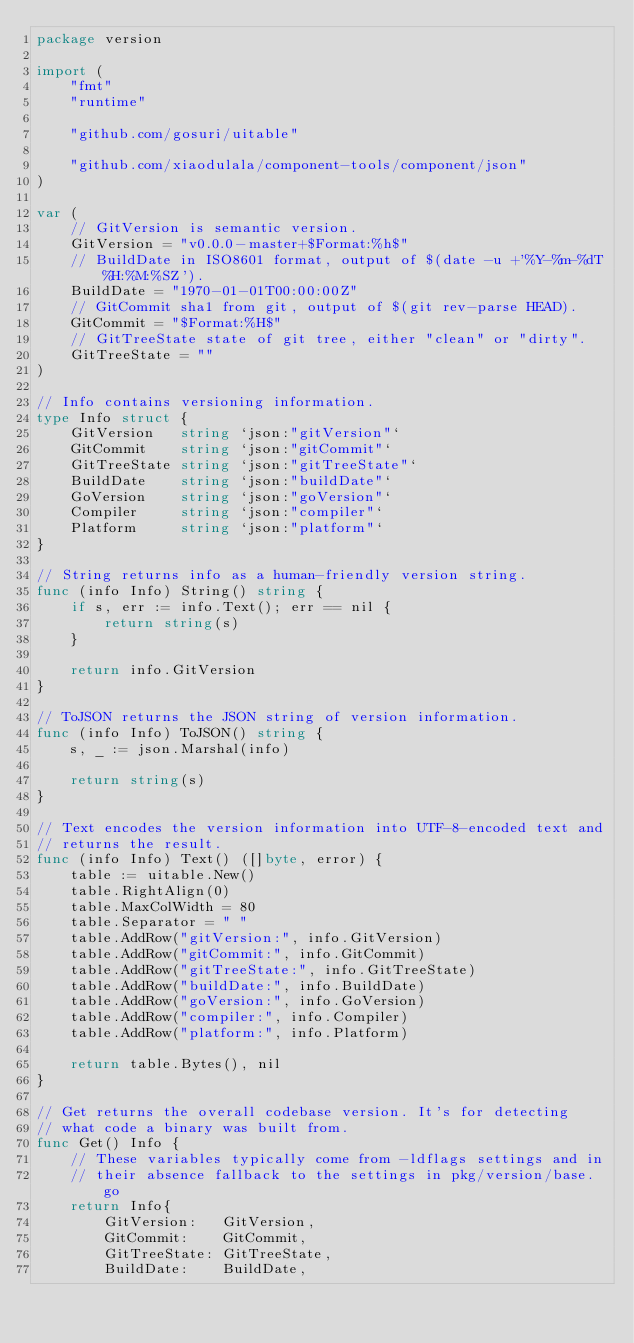<code> <loc_0><loc_0><loc_500><loc_500><_Go_>package version

import (
	"fmt"
	"runtime"

	"github.com/gosuri/uitable"

	"github.com/xiaodulala/component-tools/component/json"
)

var (
	// GitVersion is semantic version.
	GitVersion = "v0.0.0-master+$Format:%h$"
	// BuildDate in ISO8601 format, output of $(date -u +'%Y-%m-%dT%H:%M:%SZ').
	BuildDate = "1970-01-01T00:00:00Z"
	// GitCommit sha1 from git, output of $(git rev-parse HEAD).
	GitCommit = "$Format:%H$"
	// GitTreeState state of git tree, either "clean" or "dirty".
	GitTreeState = ""
)

// Info contains versioning information.
type Info struct {
	GitVersion   string `json:"gitVersion"`
	GitCommit    string `json:"gitCommit"`
	GitTreeState string `json:"gitTreeState"`
	BuildDate    string `json:"buildDate"`
	GoVersion    string `json:"goVersion"`
	Compiler     string `json:"compiler"`
	Platform     string `json:"platform"`
}

// String returns info as a human-friendly version string.
func (info Info) String() string {
	if s, err := info.Text(); err == nil {
		return string(s)
	}

	return info.GitVersion
}

// ToJSON returns the JSON string of version information.
func (info Info) ToJSON() string {
	s, _ := json.Marshal(info)

	return string(s)
}

// Text encodes the version information into UTF-8-encoded text and
// returns the result.
func (info Info) Text() ([]byte, error) {
	table := uitable.New()
	table.RightAlign(0)
	table.MaxColWidth = 80
	table.Separator = " "
	table.AddRow("gitVersion:", info.GitVersion)
	table.AddRow("gitCommit:", info.GitCommit)
	table.AddRow("gitTreeState:", info.GitTreeState)
	table.AddRow("buildDate:", info.BuildDate)
	table.AddRow("goVersion:", info.GoVersion)
	table.AddRow("compiler:", info.Compiler)
	table.AddRow("platform:", info.Platform)

	return table.Bytes(), nil
}

// Get returns the overall codebase version. It's for detecting
// what code a binary was built from.
func Get() Info {
	// These variables typically come from -ldflags settings and in
	// their absence fallback to the settings in pkg/version/base.go
	return Info{
		GitVersion:   GitVersion,
		GitCommit:    GitCommit,
		GitTreeState: GitTreeState,
		BuildDate:    BuildDate,</code> 